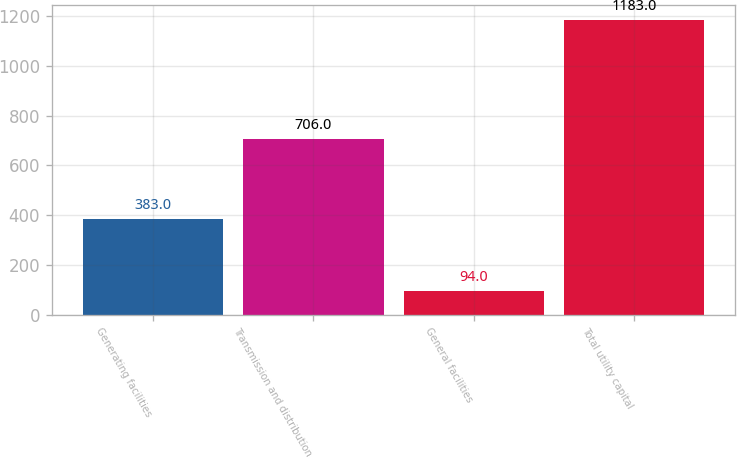Convert chart. <chart><loc_0><loc_0><loc_500><loc_500><bar_chart><fcel>Generating facilities<fcel>Transmission and distribution<fcel>General facilities<fcel>Total utility capital<nl><fcel>383<fcel>706<fcel>94<fcel>1183<nl></chart> 